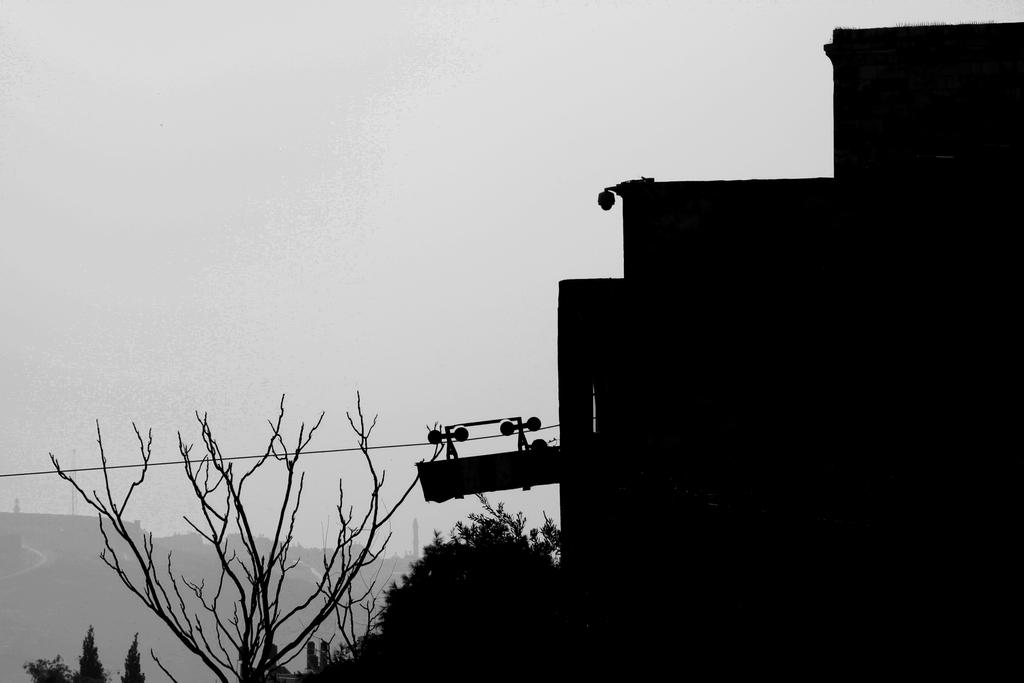What type of structure is visible in the image? There is a building in the image. What other natural elements can be seen in the image? There are trees in the image. What atmospheric condition is present in the background of the image? There is fog in the background of the image. Where is the desk located in the image? There is no desk present in the image. What type of activity is taking place during the recess in the image? There is no recess or any indication of an activity taking place in the image. 